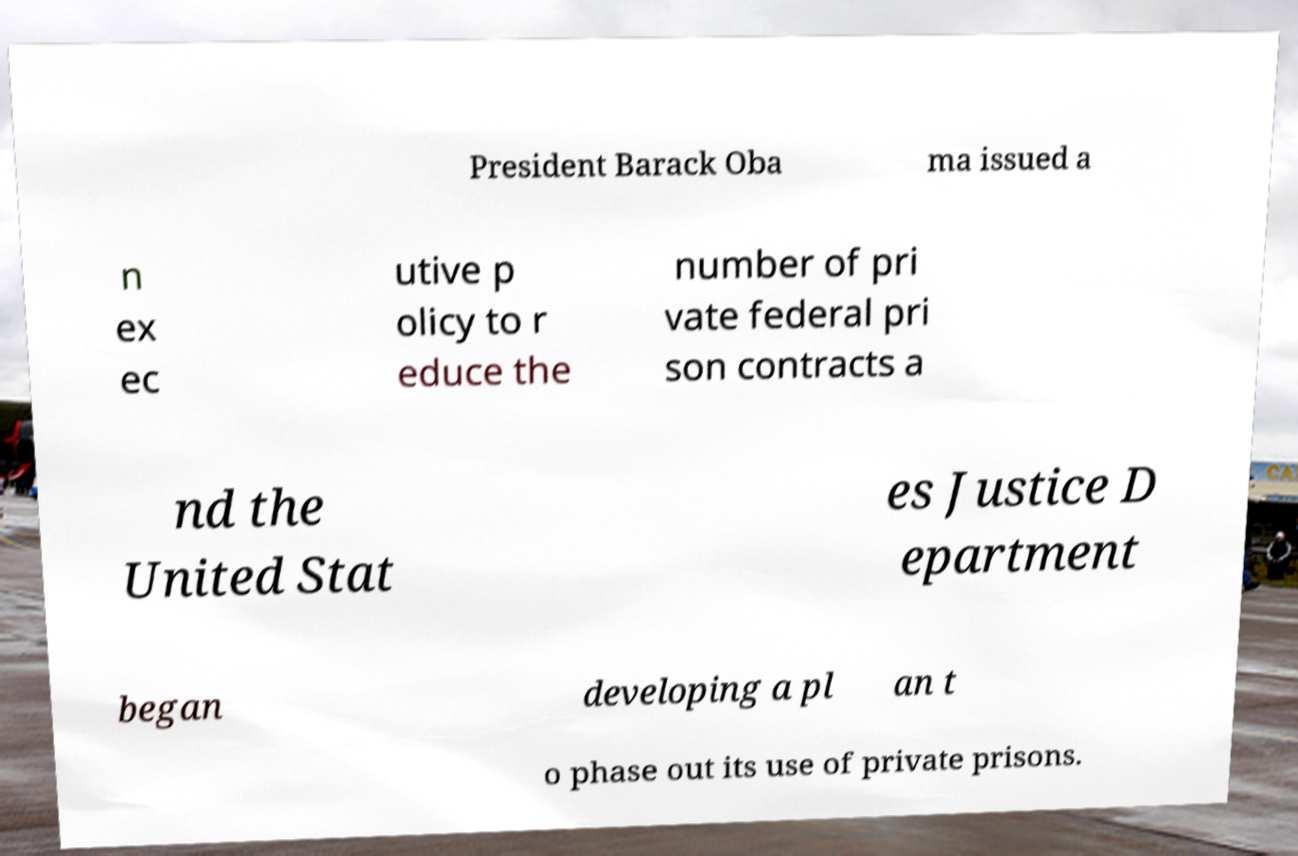What messages or text are displayed in this image? I need them in a readable, typed format. President Barack Oba ma issued a n ex ec utive p olicy to r educe the number of pri vate federal pri son contracts a nd the United Stat es Justice D epartment began developing a pl an t o phase out its use of private prisons. 